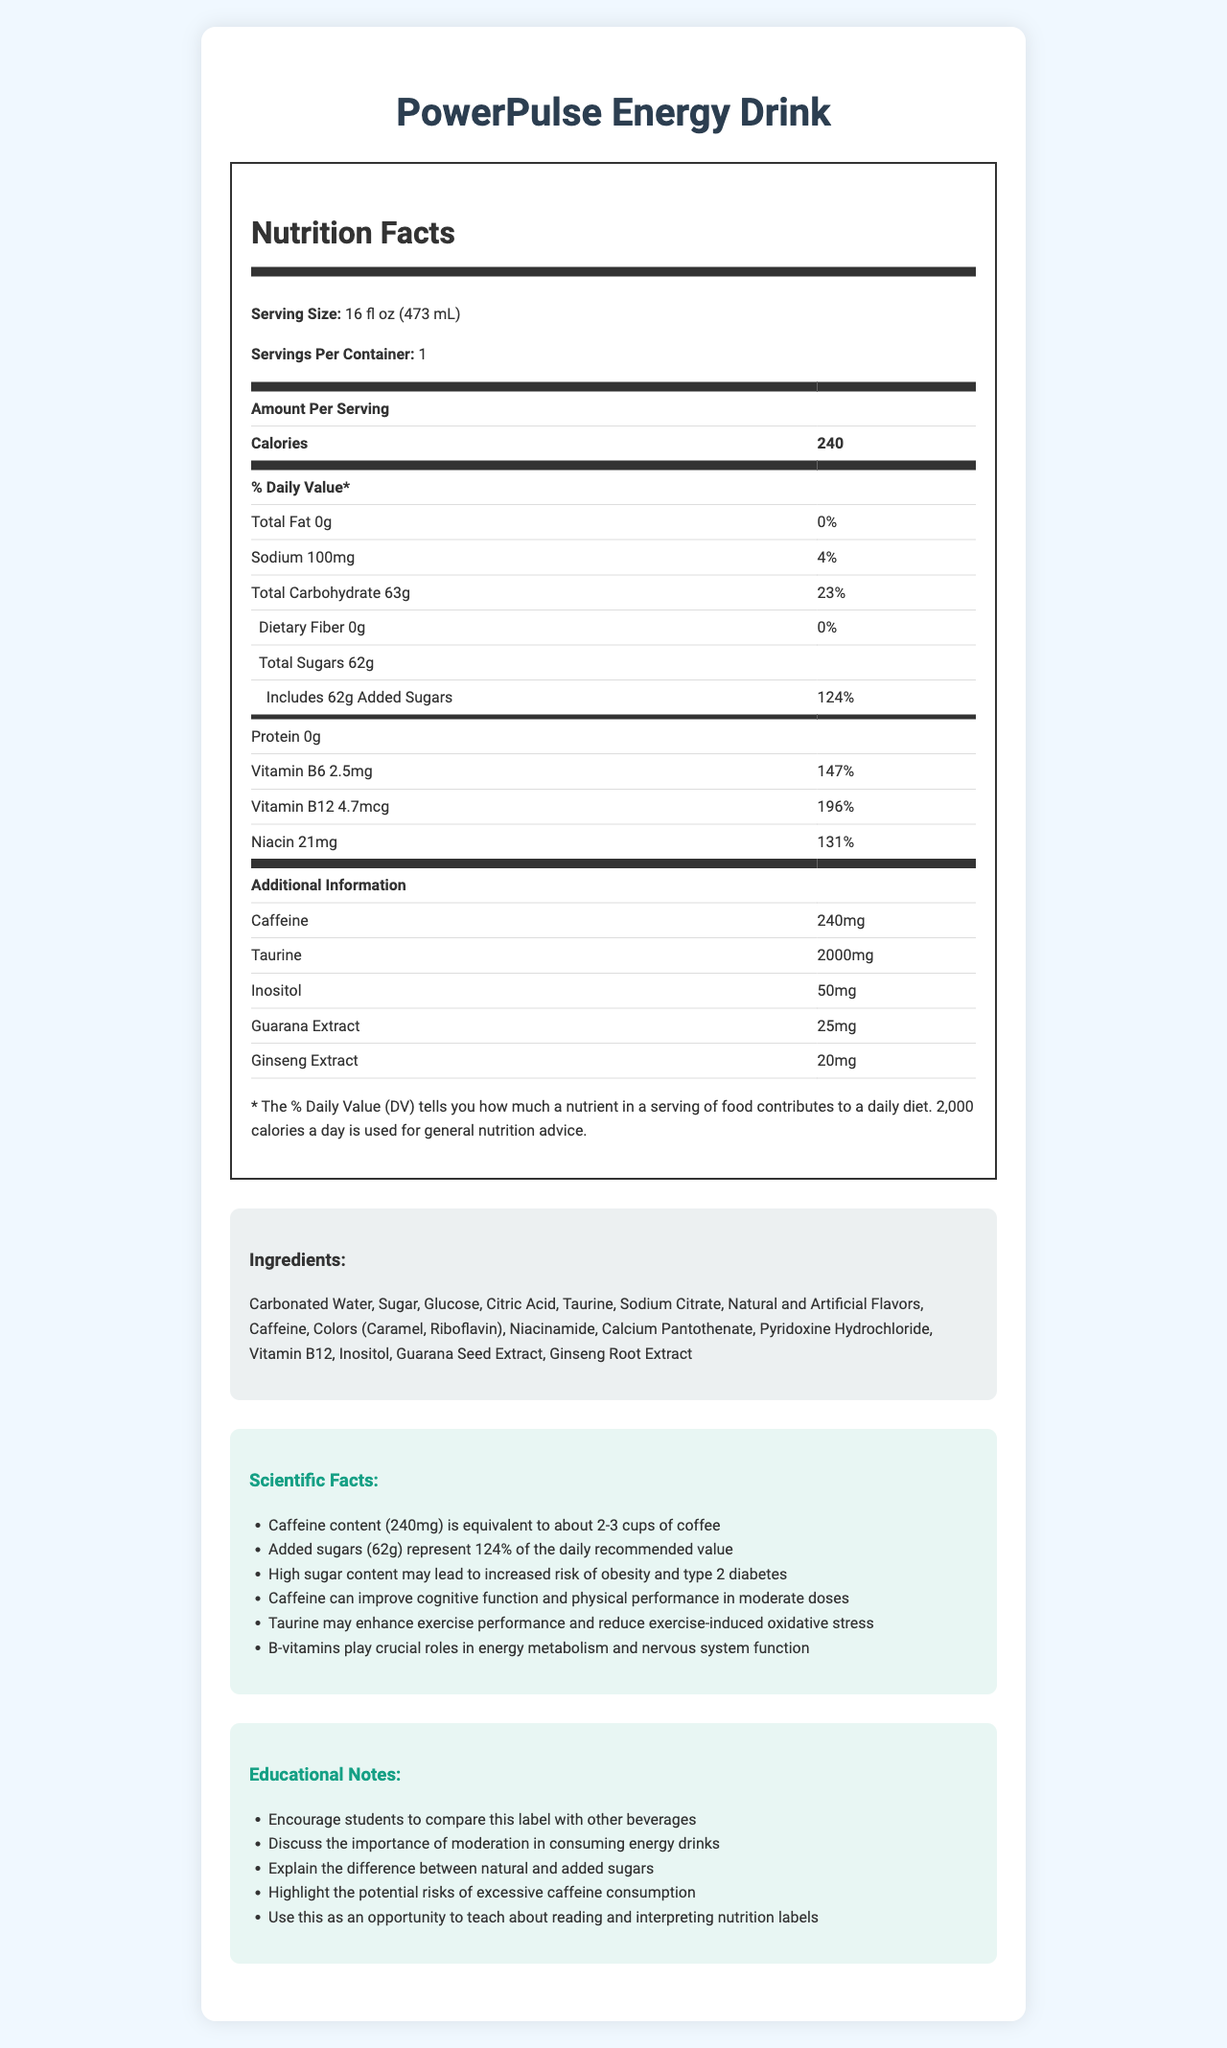1. What is the serving size of PowerPulse Energy Drink? The serving size is clearly listed at the top of the Nutrition Facts section.
Answer: 16 fl oz (473 mL) 2. How much caffeine is in one serving of the energy drink? The Nutrition Facts section lists caffeine content as 240mg per serving.
Answer: 240mg 3. What percentage of the daily value of added sugars does the drink contain? The Nutrition Facts section shows that added sugars represent 124% of the daily recommended value.
Answer: 124% 4. What is the amount of total carbohydrate per serving? The total carbohydrate content per serving is listed as 63g in the Nutrition Facts section.
Answer: 63g 5. Name three vitamins included in the drink and their respective amounts. The vitamins and their amounts are listed in the Nutrition Facts section under additional information.
Answer: Vitamin B6 (2.5mg), Vitamin B12 (4.7mcg), Niacin (21mg) 6. How does the caffeine content in the energy drink compare to the amount in coffee? a. Less than one cup of coffee b. Equivalent to about 2-3 cups of coffee c. Equivalent to one cup of coffee d. More than 3 cups of coffee The scientific facts section states that the caffeine content (240mg) is equivalent to about 2-3 cups of coffee.
Answer: b. Equivalent to about 2-3 cups of coffee 7. What is the primary difference highlighted between natural and added sugars? a. Their origin b. Their taste c. Their nutritional value d. Their chemical structure The educational notes suggest a discussion on the difference between natural and added sugars.
Answer: a. Their origin 8. Is the statement "This drink contains fiber" true or false? The Nutrition Facts section shows that the dietary fiber content is 0g.
Answer: False 9. What are the potential risks associated with high sugar content according to the scientific facts? The scientific facts mention that high sugar content may lead to an increased risk of obesity and type 2 diabetes.
Answer: Increased risk of obesity and type 2 diabetes 10. Why is it important to moderate the consumption of energy drinks according to the educational notes? The educational notes emphasize the importance of moderation in consuming energy drinks due to potential health risks.
Answer: To avoid the potential risks of excessive sugar and caffeine intake 11. What does the document primarily focus on? The document contains sections on Nutrition Facts, Ingredients, Scientific Facts, and Educational Notes, providing a comprehensive overview of the energy drink's composition and health impact.
Answer: The document provides detailed nutritional information, scientific facts, and educational notes about the PowerPulse Energy Drink. It emphasizes the caffeine and sugar content and discusses the health implications and importance of moderation while consuming such beverages. 12. How much Taurine is in the drink? The amount of Taurine is listed in the Nutrition Facts section under additional information.
Answer: 2000mg 13. What is one of the key educational topics encouraged for discussion? The educational notes specifically suggest discussing the importance of moderation in consuming energy drinks.
Answer: The importance of moderation in consuming energy drinks 14. What are the main ingredients in PowerPulse Energy Drink? The ingredient list provides a comprehensive breakdown of the main components used in the drink.
Answer: Carbonated Water, Sugar, Glucose, Citric Acid, Taurine, Sodium Citrate, Natural and Artificial Flavors, Caffeine, Colors (Caramel, Riboflavin), Niacinamide, Calcium Pantothenate, Pyridoxine Hydrochloride, Vitamin B12, Inositol, Guarana Seed Extract, Ginseng Root Extract 15. What health benefit is associated with caffeine according to the scientific facts? The scientific facts section lists caffeine's benefits in improving cognitive function and physical performance when consumed in moderate doses.
Answer: Improving cognitive function and physical performance in moderate doses 16. What is the exact amount of sodium in one serving? The Nutrition Facts section specifies the sodium content as 100mg per serving.
Answer: 100mg 17. How much protein does PowerPulse Energy Drink contain? The protein content is listed as 0g in the Nutrition Facts section.
Answer: 0g 18. Can the exact manufacturing process of the energy drink be determined from this document? The document does not provide any details on the manufacturing process of the energy drink, so it cannot be determined from the given information.
Answer: Cannot be determined 